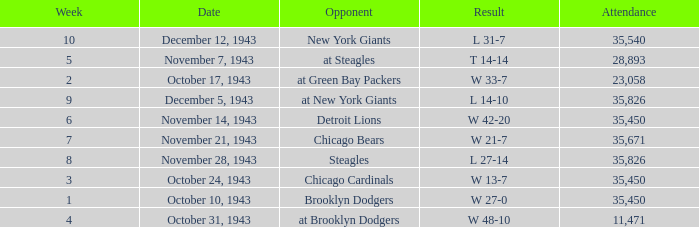How many attendances have 9 as the week? 1.0. Parse the full table. {'header': ['Week', 'Date', 'Opponent', 'Result', 'Attendance'], 'rows': [['10', 'December 12, 1943', 'New York Giants', 'L 31-7', '35,540'], ['5', 'November 7, 1943', 'at Steagles', 'T 14-14', '28,893'], ['2', 'October 17, 1943', 'at Green Bay Packers', 'W 33-7', '23,058'], ['9', 'December 5, 1943', 'at New York Giants', 'L 14-10', '35,826'], ['6', 'November 14, 1943', 'Detroit Lions', 'W 42-20', '35,450'], ['7', 'November 21, 1943', 'Chicago Bears', 'W 21-7', '35,671'], ['8', 'November 28, 1943', 'Steagles', 'L 27-14', '35,826'], ['3', 'October 24, 1943', 'Chicago Cardinals', 'W 13-7', '35,450'], ['1', 'October 10, 1943', 'Brooklyn Dodgers', 'W 27-0', '35,450'], ['4', 'October 31, 1943', 'at Brooklyn Dodgers', 'W 48-10', '11,471']]} 